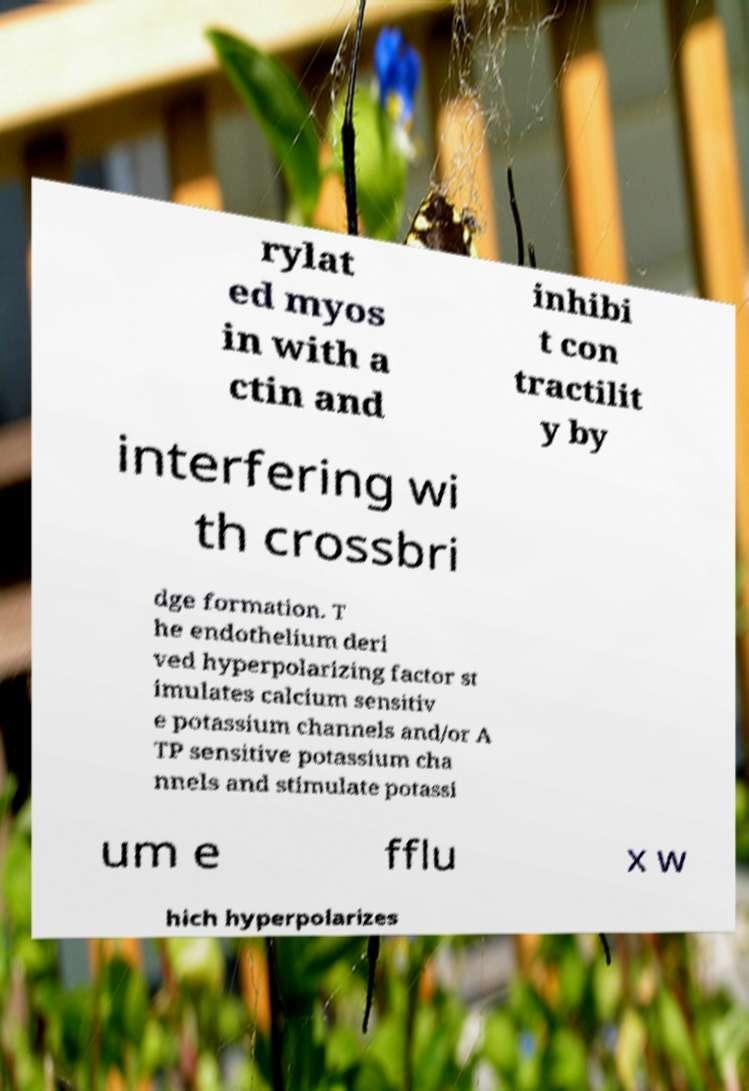Please read and relay the text visible in this image. What does it say? rylat ed myos in with a ctin and inhibi t con tractilit y by interfering wi th crossbri dge formation. T he endothelium deri ved hyperpolarizing factor st imulates calcium sensitiv e potassium channels and/or A TP sensitive potassium cha nnels and stimulate potassi um e fflu x w hich hyperpolarizes 